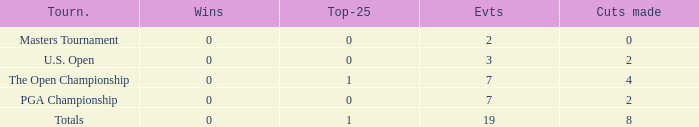What is the lowest Top-25 that has 3 Events and Wins greater than 0? None. 